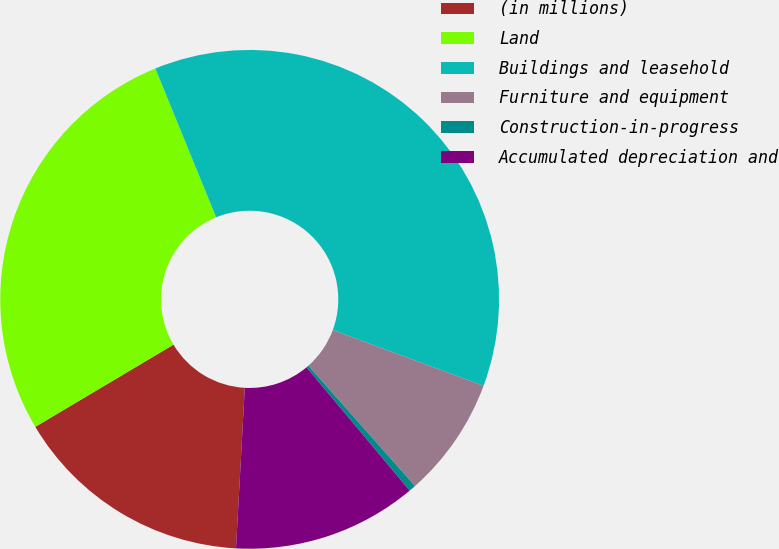Convert chart to OTSL. <chart><loc_0><loc_0><loc_500><loc_500><pie_chart><fcel>(in millions)<fcel>Land<fcel>Buildings and leasehold<fcel>Furniture and equipment<fcel>Construction-in-progress<fcel>Accumulated depreciation and<nl><fcel>15.59%<fcel>27.37%<fcel>36.81%<fcel>7.83%<fcel>0.45%<fcel>11.96%<nl></chart> 